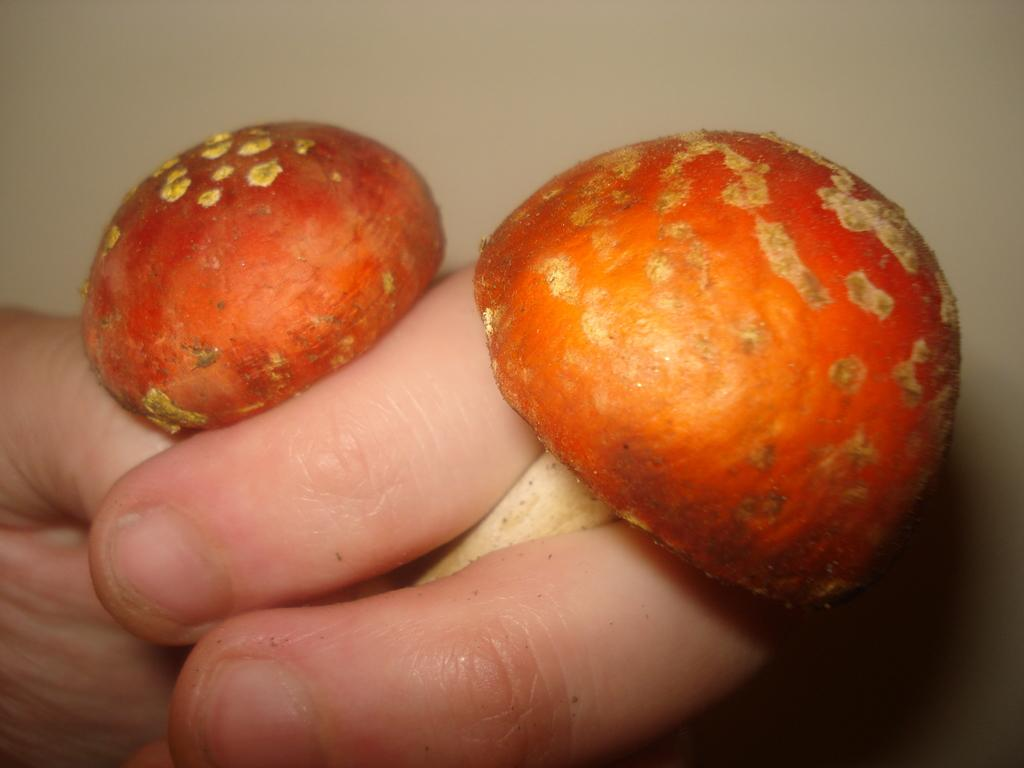What is the main subject of the image? There is a person in the image. What is the person holding in the image? The person is holding two mushrooms. What type of grain can be seen growing in the image? There is no grain visible in the image; it features a person holding two mushrooms. Can you describe the tiger's behavior in the image? There is no tiger present in the image. 